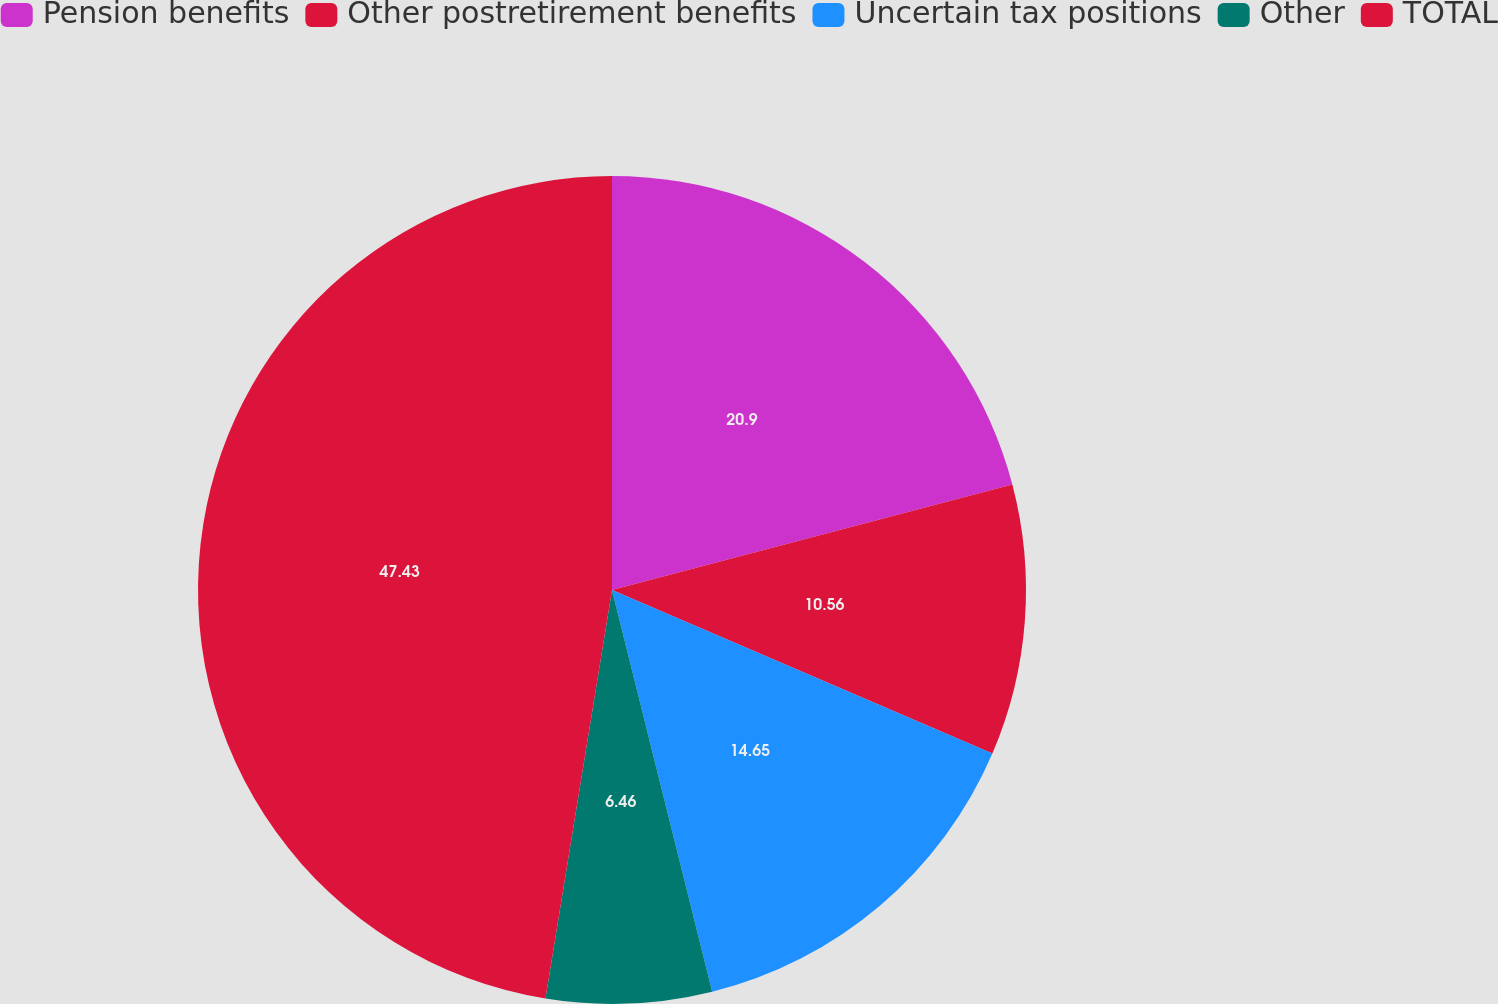<chart> <loc_0><loc_0><loc_500><loc_500><pie_chart><fcel>Pension benefits<fcel>Other postretirement benefits<fcel>Uncertain tax positions<fcel>Other<fcel>TOTAL<nl><fcel>20.9%<fcel>10.56%<fcel>14.65%<fcel>6.46%<fcel>47.43%<nl></chart> 